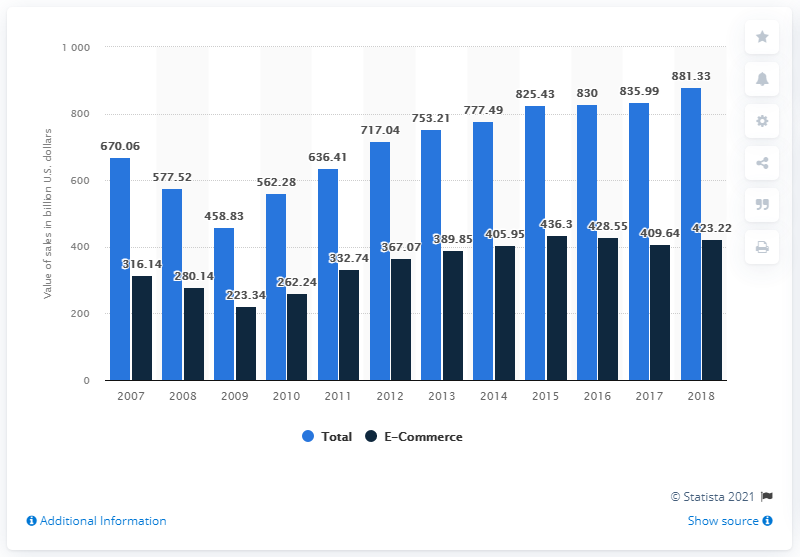Give some essential details in this illustration. In 2018, the e-commerce value of motor vehicle and motor vehicle parts and supplies sales reached approximately $423.22. 